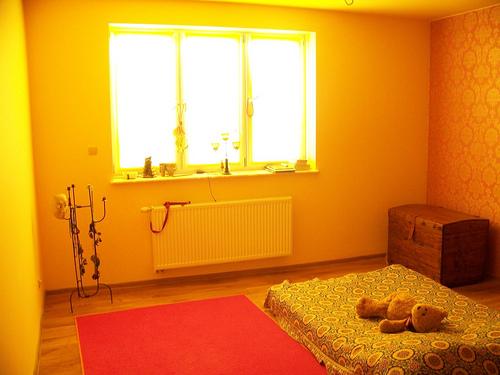Is this a kids room?
Concise answer only. Yes. What is that white thing on the wall?
Be succinct. Radiator. What is on the bed?
Write a very short answer. Teddy bear. 